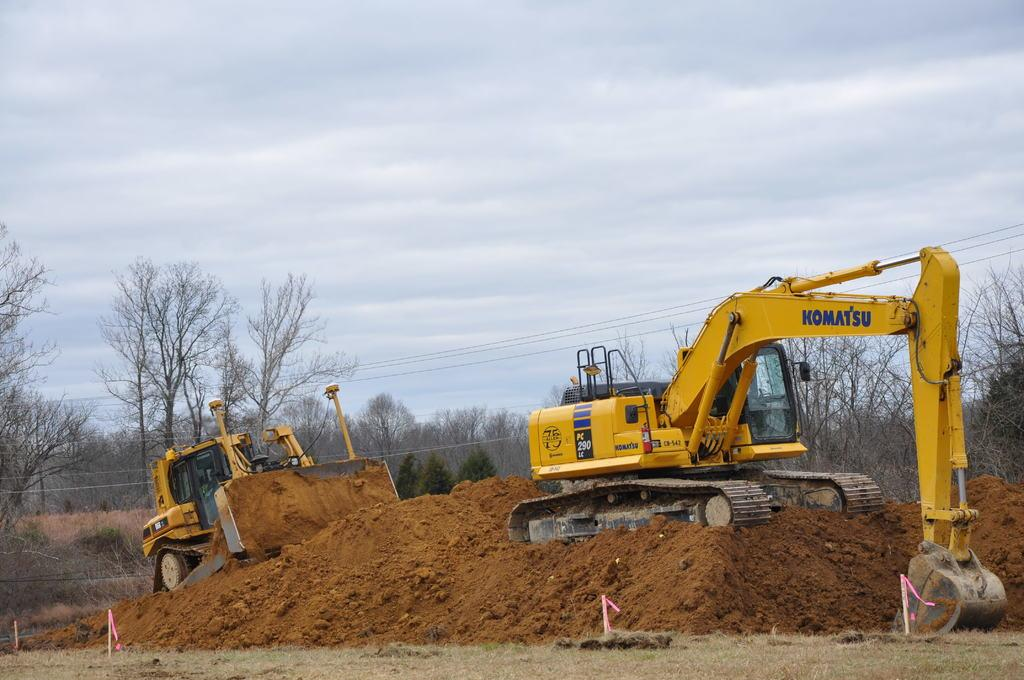What type of machinery can be seen in the image? There are cranes in the image. What type of terrain is visible in the image? Soil is visible in the image. What type of vegetation is present in the image? Trees are present in the image. What is the condition of the sky in the image? The sky is cloudy in the image. Where is the hydrant located in the image? There is no hydrant present in the image. What part of the crane is shown in the image? The entire crane is visible in the image, so it is not possible to identify a specific part. 